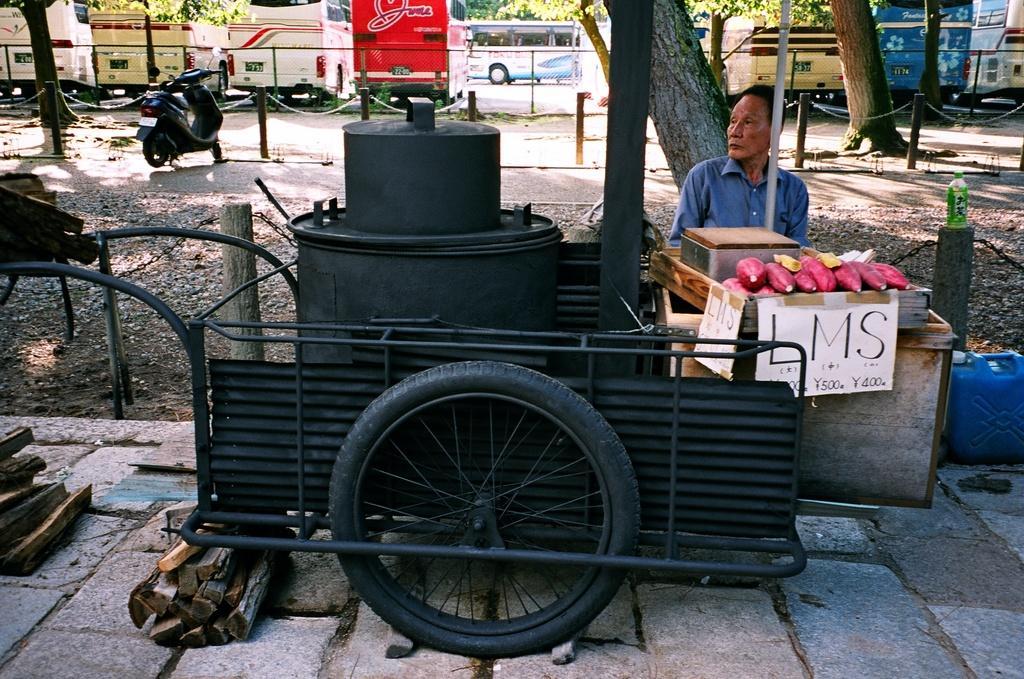Can you describe this image briefly? In this image we can see a person, fruits, poster, wheel, poles, bottle, wooden sticks, bike, road, and few objects. In the background we can see vehicles, fence, and trees. 